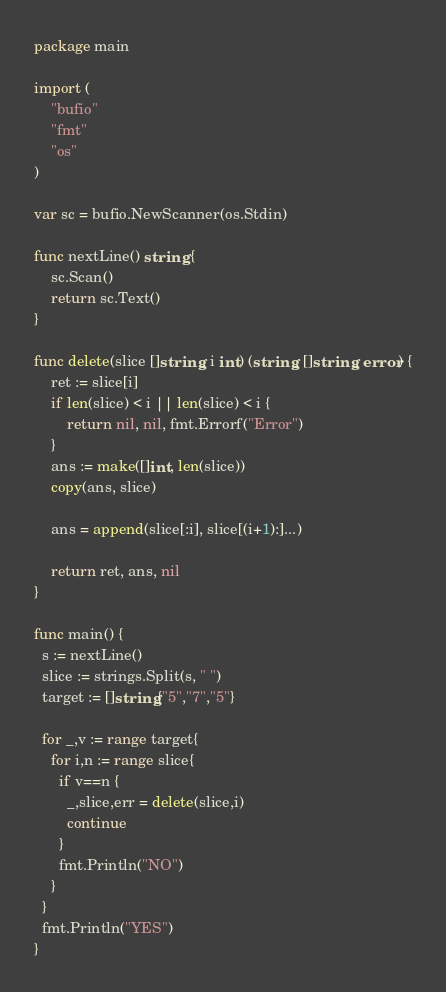<code> <loc_0><loc_0><loc_500><loc_500><_Go_>package main
 
import (
    "bufio"
    "fmt"
    "os"
)
 
var sc = bufio.NewScanner(os.Stdin)
 
func nextLine() string {
    sc.Scan()
    return sc.Text()
}
 
func delete(slice []string, i int) (string, []string, error) {
    ret := slice[i]
    if len(slice) < i || len(slice) < i {
        return nil, nil, fmt.Errorf("Error")
    }
    ans := make([]int, len(slice))
    copy(ans, slice)
 
    ans = append(slice[:i], slice[(i+1):]...)
 
    return ret, ans, nil
}
 
func main() {
  s := nextLine()
  slice := strings.Split(s, " ")
  target := []string{"5","7","5"}
  
  for _,v := range target{
    for i,n := range slice{
      if v==n {
        _,slice,err = delete(slice,i)
        continue
      }
      fmt.Println("NO")
    }
  }
  fmt.Println("YES")
}</code> 